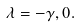Convert formula to latex. <formula><loc_0><loc_0><loc_500><loc_500>\lambda = - \gamma , 0 .</formula> 